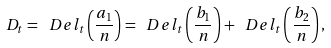Convert formula to latex. <formula><loc_0><loc_0><loc_500><loc_500>D _ { t } = \ D e l _ { t } \left ( \frac { a _ { 1 } } n \right ) = \ D e l _ { t } \left ( \frac { b _ { 1 } } n \right ) + \ D e l _ { t } \left ( \frac { b _ { 2 } } n \right ) ,</formula> 